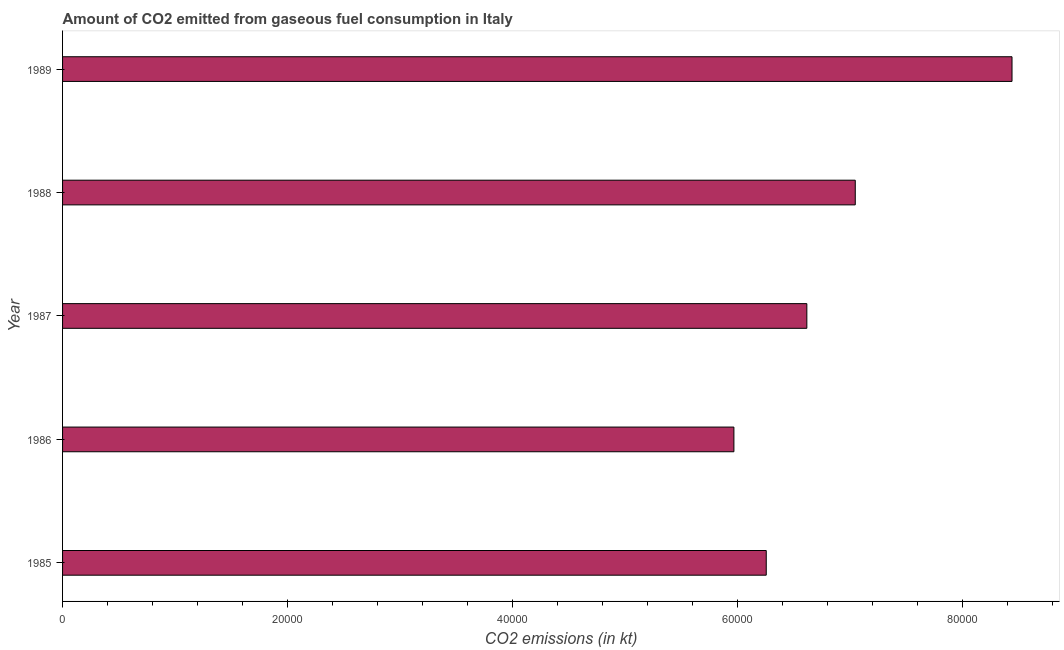Does the graph contain grids?
Keep it short and to the point. No. What is the title of the graph?
Your answer should be compact. Amount of CO2 emitted from gaseous fuel consumption in Italy. What is the label or title of the X-axis?
Your answer should be very brief. CO2 emissions (in kt). What is the co2 emissions from gaseous fuel consumption in 1986?
Your answer should be very brief. 5.97e+04. Across all years, what is the maximum co2 emissions from gaseous fuel consumption?
Your answer should be compact. 8.44e+04. Across all years, what is the minimum co2 emissions from gaseous fuel consumption?
Make the answer very short. 5.97e+04. What is the sum of the co2 emissions from gaseous fuel consumption?
Ensure brevity in your answer.  3.43e+05. What is the difference between the co2 emissions from gaseous fuel consumption in 1985 and 1989?
Offer a terse response. -2.18e+04. What is the average co2 emissions from gaseous fuel consumption per year?
Your response must be concise. 6.87e+04. What is the median co2 emissions from gaseous fuel consumption?
Offer a terse response. 6.62e+04. In how many years, is the co2 emissions from gaseous fuel consumption greater than 68000 kt?
Your answer should be very brief. 2. What is the ratio of the co2 emissions from gaseous fuel consumption in 1987 to that in 1988?
Your answer should be very brief. 0.94. Is the co2 emissions from gaseous fuel consumption in 1985 less than that in 1988?
Provide a succinct answer. Yes. Is the difference between the co2 emissions from gaseous fuel consumption in 1985 and 1986 greater than the difference between any two years?
Ensure brevity in your answer.  No. What is the difference between the highest and the second highest co2 emissions from gaseous fuel consumption?
Keep it short and to the point. 1.39e+04. What is the difference between the highest and the lowest co2 emissions from gaseous fuel consumption?
Your answer should be compact. 2.47e+04. What is the difference between two consecutive major ticks on the X-axis?
Ensure brevity in your answer.  2.00e+04. Are the values on the major ticks of X-axis written in scientific E-notation?
Your answer should be very brief. No. What is the CO2 emissions (in kt) of 1985?
Make the answer very short. 6.26e+04. What is the CO2 emissions (in kt) of 1986?
Give a very brief answer. 5.97e+04. What is the CO2 emissions (in kt) of 1987?
Your answer should be very brief. 6.62e+04. What is the CO2 emissions (in kt) of 1988?
Ensure brevity in your answer.  7.05e+04. What is the CO2 emissions (in kt) in 1989?
Your response must be concise. 8.44e+04. What is the difference between the CO2 emissions (in kt) in 1985 and 1986?
Offer a very short reply. 2874.93. What is the difference between the CO2 emissions (in kt) in 1985 and 1987?
Make the answer very short. -3608.33. What is the difference between the CO2 emissions (in kt) in 1985 and 1988?
Keep it short and to the point. -7913.39. What is the difference between the CO2 emissions (in kt) in 1985 and 1989?
Your response must be concise. -2.18e+04. What is the difference between the CO2 emissions (in kt) in 1986 and 1987?
Provide a succinct answer. -6483.26. What is the difference between the CO2 emissions (in kt) in 1986 and 1988?
Offer a very short reply. -1.08e+04. What is the difference between the CO2 emissions (in kt) in 1986 and 1989?
Ensure brevity in your answer.  -2.47e+04. What is the difference between the CO2 emissions (in kt) in 1987 and 1988?
Ensure brevity in your answer.  -4305.06. What is the difference between the CO2 emissions (in kt) in 1987 and 1989?
Your answer should be compact. -1.82e+04. What is the difference between the CO2 emissions (in kt) in 1988 and 1989?
Provide a succinct answer. -1.39e+04. What is the ratio of the CO2 emissions (in kt) in 1985 to that in 1986?
Your response must be concise. 1.05. What is the ratio of the CO2 emissions (in kt) in 1985 to that in 1987?
Ensure brevity in your answer.  0.94. What is the ratio of the CO2 emissions (in kt) in 1985 to that in 1988?
Offer a terse response. 0.89. What is the ratio of the CO2 emissions (in kt) in 1985 to that in 1989?
Provide a short and direct response. 0.74. What is the ratio of the CO2 emissions (in kt) in 1986 to that in 1987?
Provide a short and direct response. 0.9. What is the ratio of the CO2 emissions (in kt) in 1986 to that in 1988?
Your response must be concise. 0.85. What is the ratio of the CO2 emissions (in kt) in 1986 to that in 1989?
Keep it short and to the point. 0.71. What is the ratio of the CO2 emissions (in kt) in 1987 to that in 1988?
Provide a succinct answer. 0.94. What is the ratio of the CO2 emissions (in kt) in 1987 to that in 1989?
Provide a short and direct response. 0.78. What is the ratio of the CO2 emissions (in kt) in 1988 to that in 1989?
Provide a succinct answer. 0.83. 